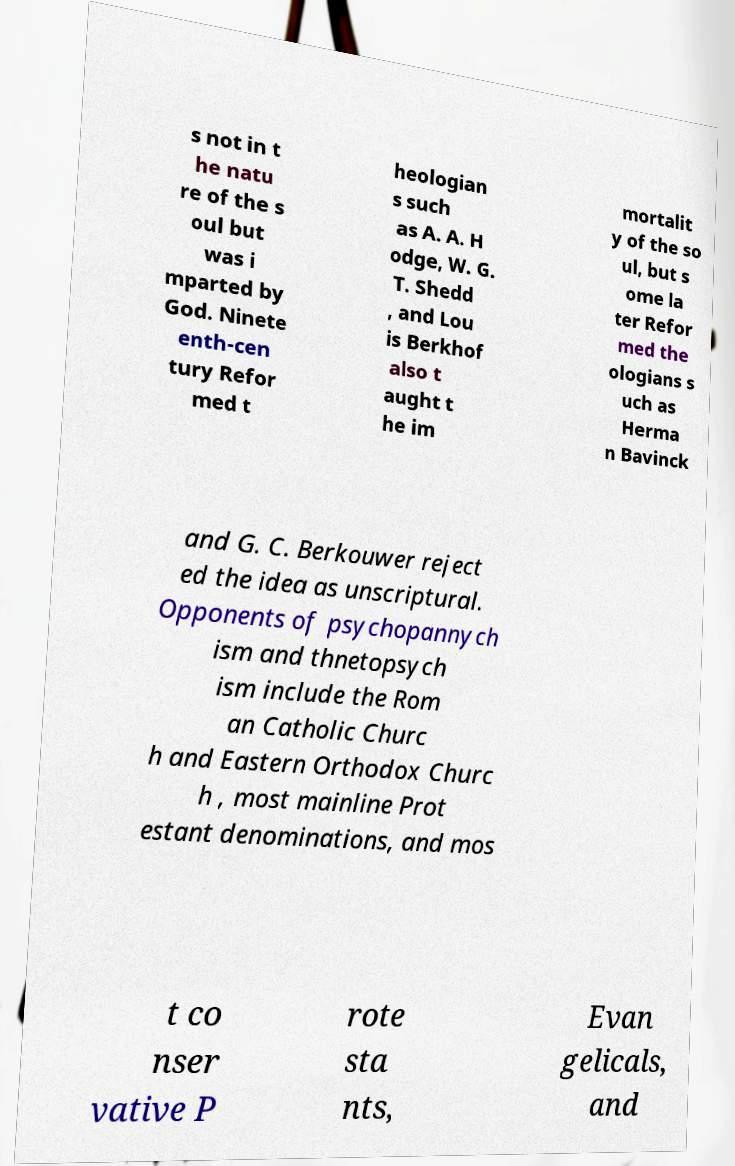Please identify and transcribe the text found in this image. s not in t he natu re of the s oul but was i mparted by God. Ninete enth-cen tury Refor med t heologian s such as A. A. H odge, W. G. T. Shedd , and Lou is Berkhof also t aught t he im mortalit y of the so ul, but s ome la ter Refor med the ologians s uch as Herma n Bavinck and G. C. Berkouwer reject ed the idea as unscriptural. Opponents of psychopannych ism and thnetopsych ism include the Rom an Catholic Churc h and Eastern Orthodox Churc h , most mainline Prot estant denominations, and mos t co nser vative P rote sta nts, Evan gelicals, and 